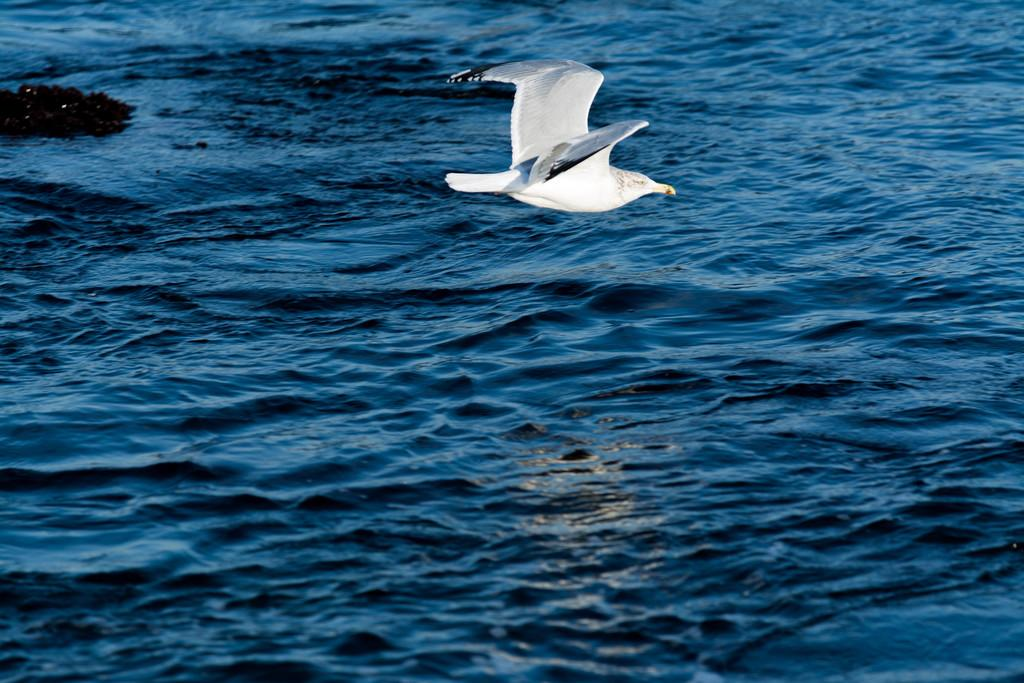What is the main subject of the image? There is a white color bird in the center of the image. What is located at the bottom of the image? There is water at the bottom of the image. What type of drug is being administered to the bird in the image? There is no drug present in the image, as it features a bird and water. 